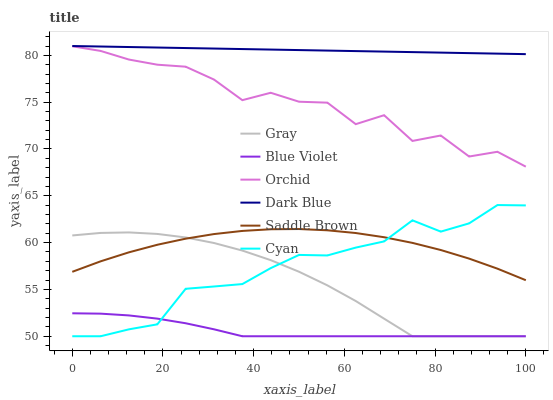Does Blue Violet have the minimum area under the curve?
Answer yes or no. Yes. Does Dark Blue have the maximum area under the curve?
Answer yes or no. Yes. Does Cyan have the minimum area under the curve?
Answer yes or no. No. Does Cyan have the maximum area under the curve?
Answer yes or no. No. Is Dark Blue the smoothest?
Answer yes or no. Yes. Is Orchid the roughest?
Answer yes or no. Yes. Is Cyan the smoothest?
Answer yes or no. No. Is Cyan the roughest?
Answer yes or no. No. Does Gray have the lowest value?
Answer yes or no. Yes. Does Dark Blue have the lowest value?
Answer yes or no. No. Does Dark Blue have the highest value?
Answer yes or no. Yes. Does Cyan have the highest value?
Answer yes or no. No. Is Saddle Brown less than Dark Blue?
Answer yes or no. Yes. Is Dark Blue greater than Saddle Brown?
Answer yes or no. Yes. Does Saddle Brown intersect Gray?
Answer yes or no. Yes. Is Saddle Brown less than Gray?
Answer yes or no. No. Is Saddle Brown greater than Gray?
Answer yes or no. No. Does Saddle Brown intersect Dark Blue?
Answer yes or no. No. 